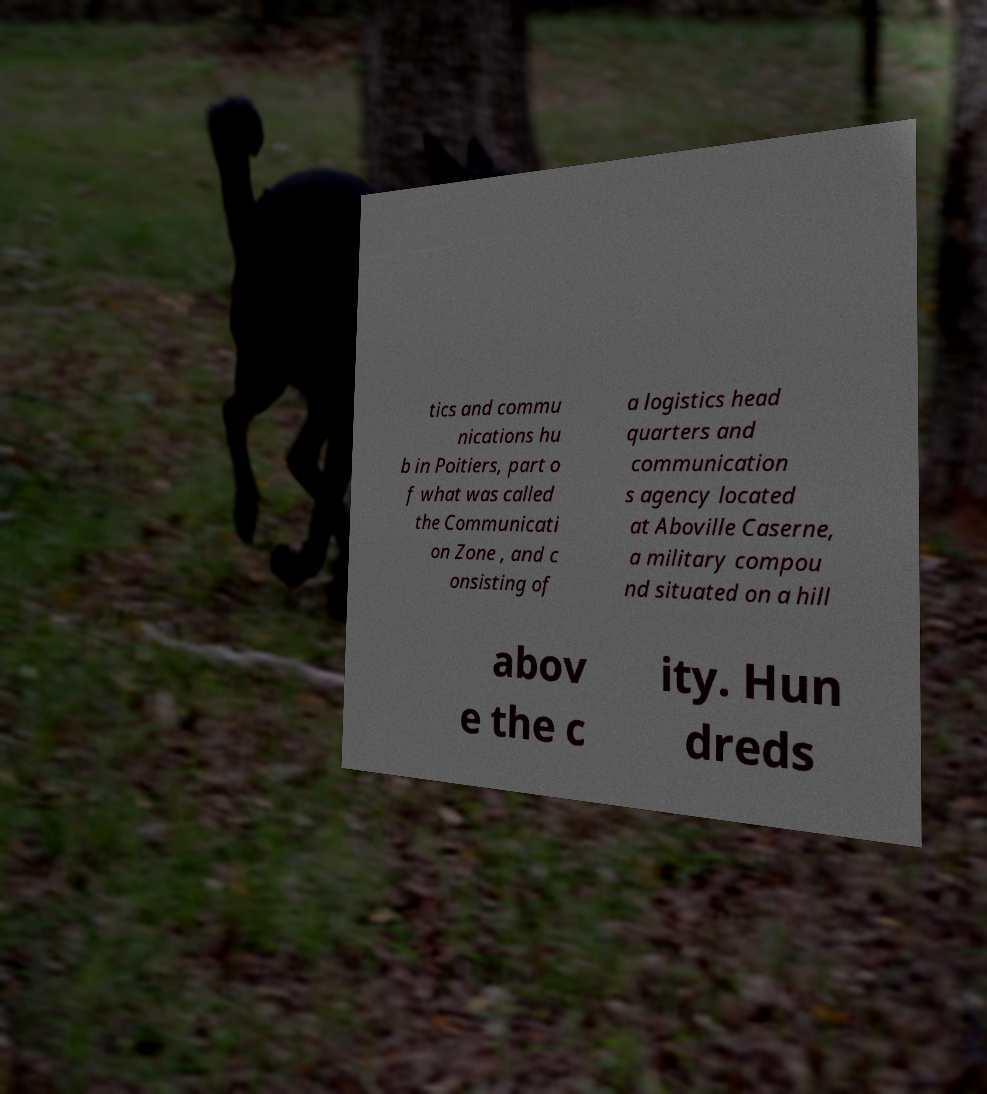Please read and relay the text visible in this image. What does it say? tics and commu nications hu b in Poitiers, part o f what was called the Communicati on Zone , and c onsisting of a logistics head quarters and communication s agency located at Aboville Caserne, a military compou nd situated on a hill abov e the c ity. Hun dreds 